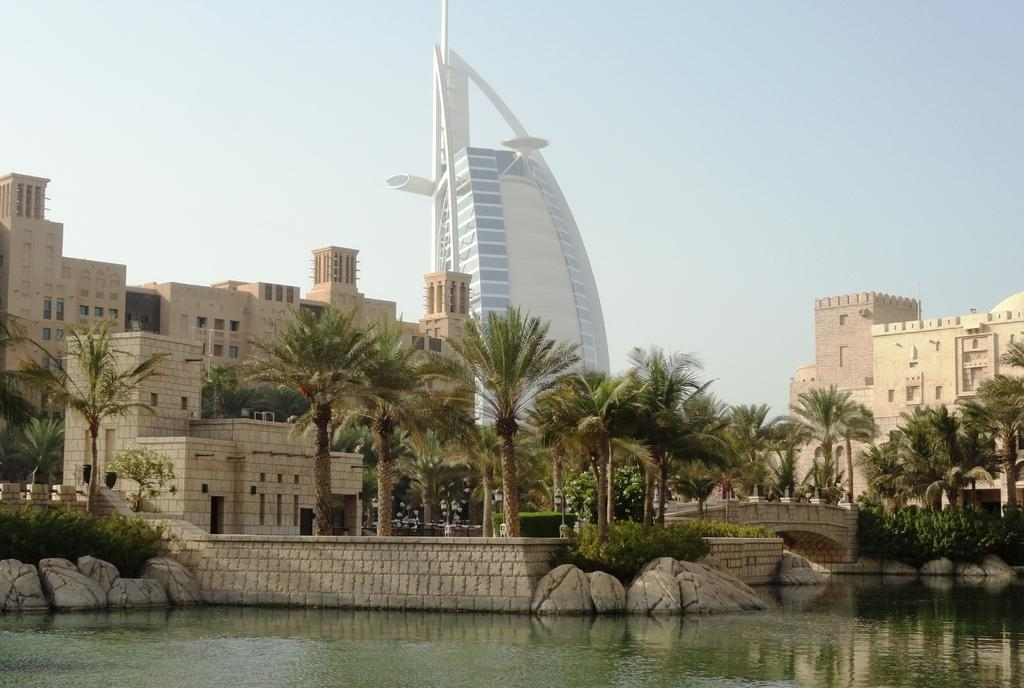What is present in the picture that is not solid? There is water in the picture. What type of natural features can be seen in the picture? There are rocks, shrubs, trees, and water in the picture. Are there any man-made structures visible in the picture? Yes, there are buildings in the picture. What can be seen in the background of the picture? The sky is visible in the background of the picture. Can you see any nets used for fishing in the picture? There is no net visible in the picture. What type of clover is growing near the water in the picture? There is no clover present in the picture. 